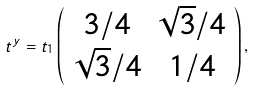<formula> <loc_0><loc_0><loc_500><loc_500>t ^ { y } = t _ { 1 } \left ( \begin{array} { c c } 3 / 4 & \sqrt { 3 } / 4 \\ \sqrt { 3 } / 4 & 1 / 4 \\ \end{array} \right ) ,</formula> 